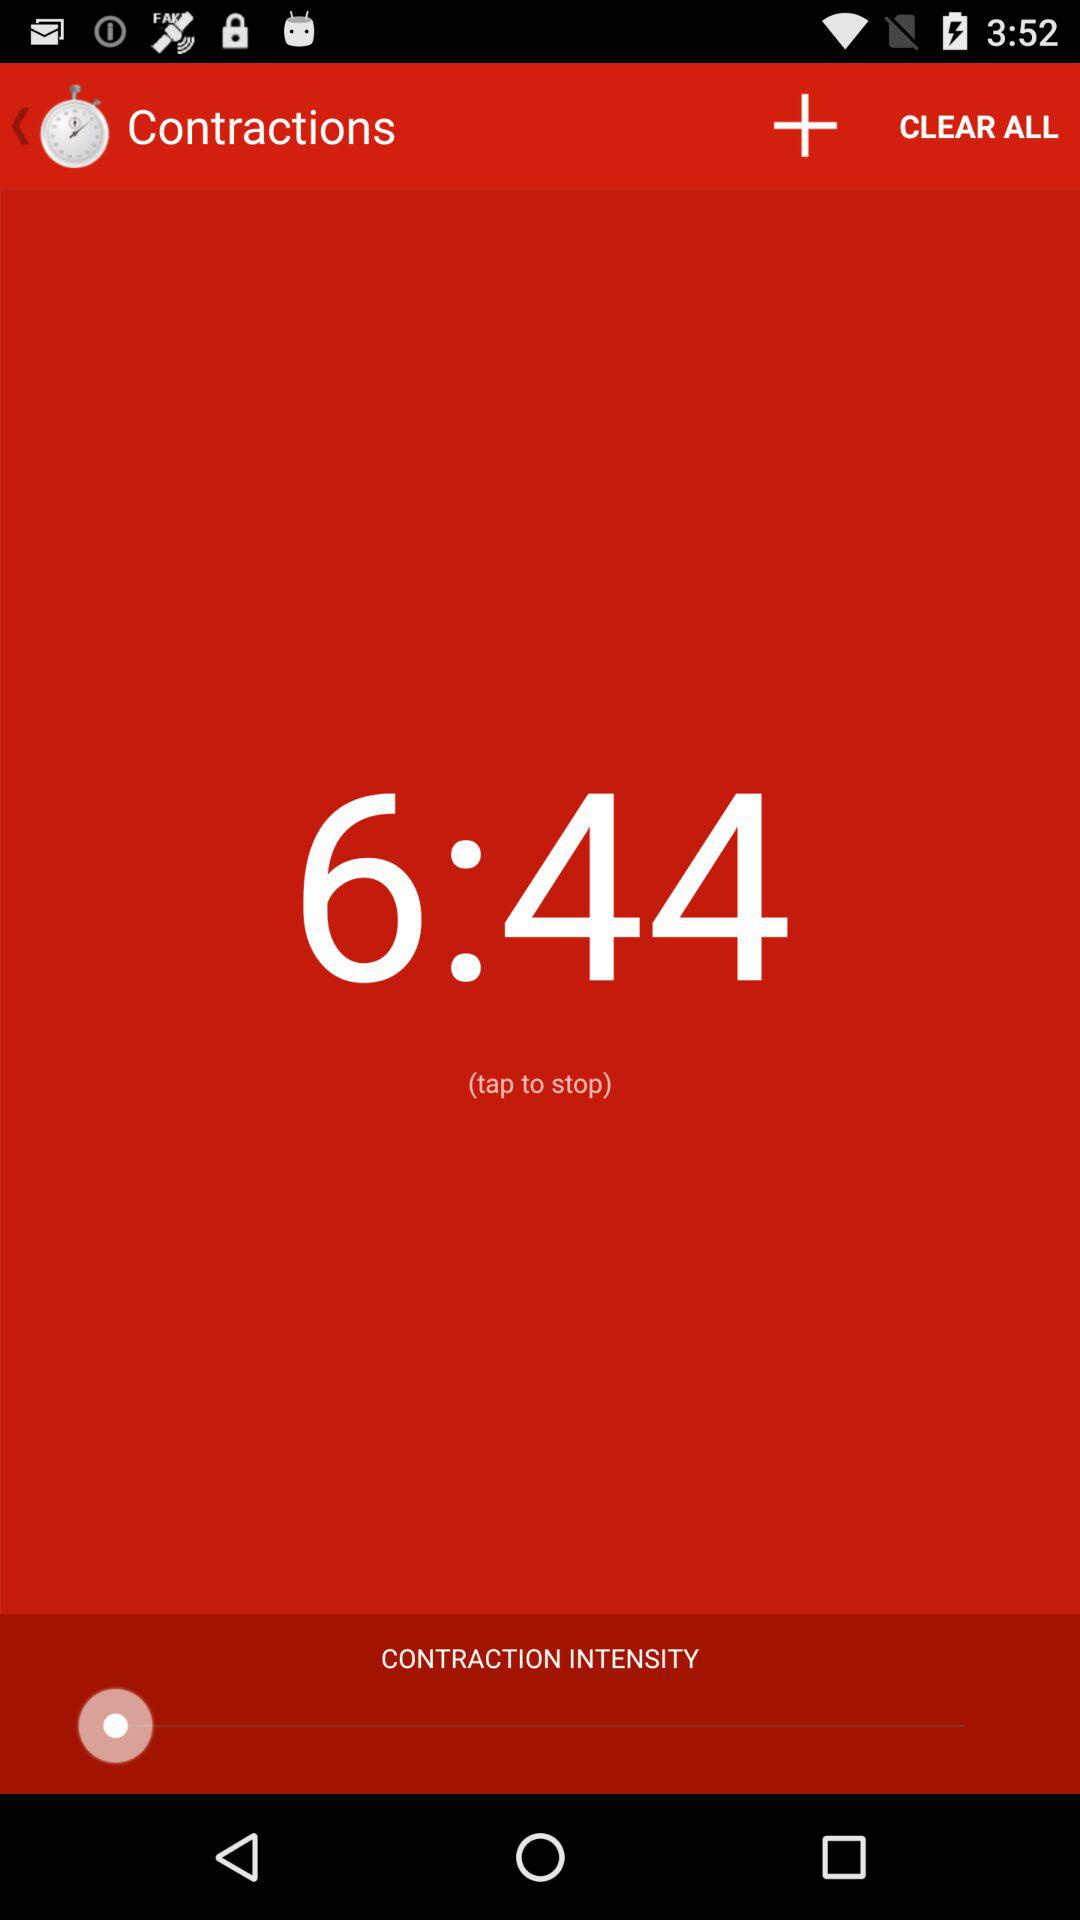What is the duration? The duration is 6 minutes 44 seconds. 